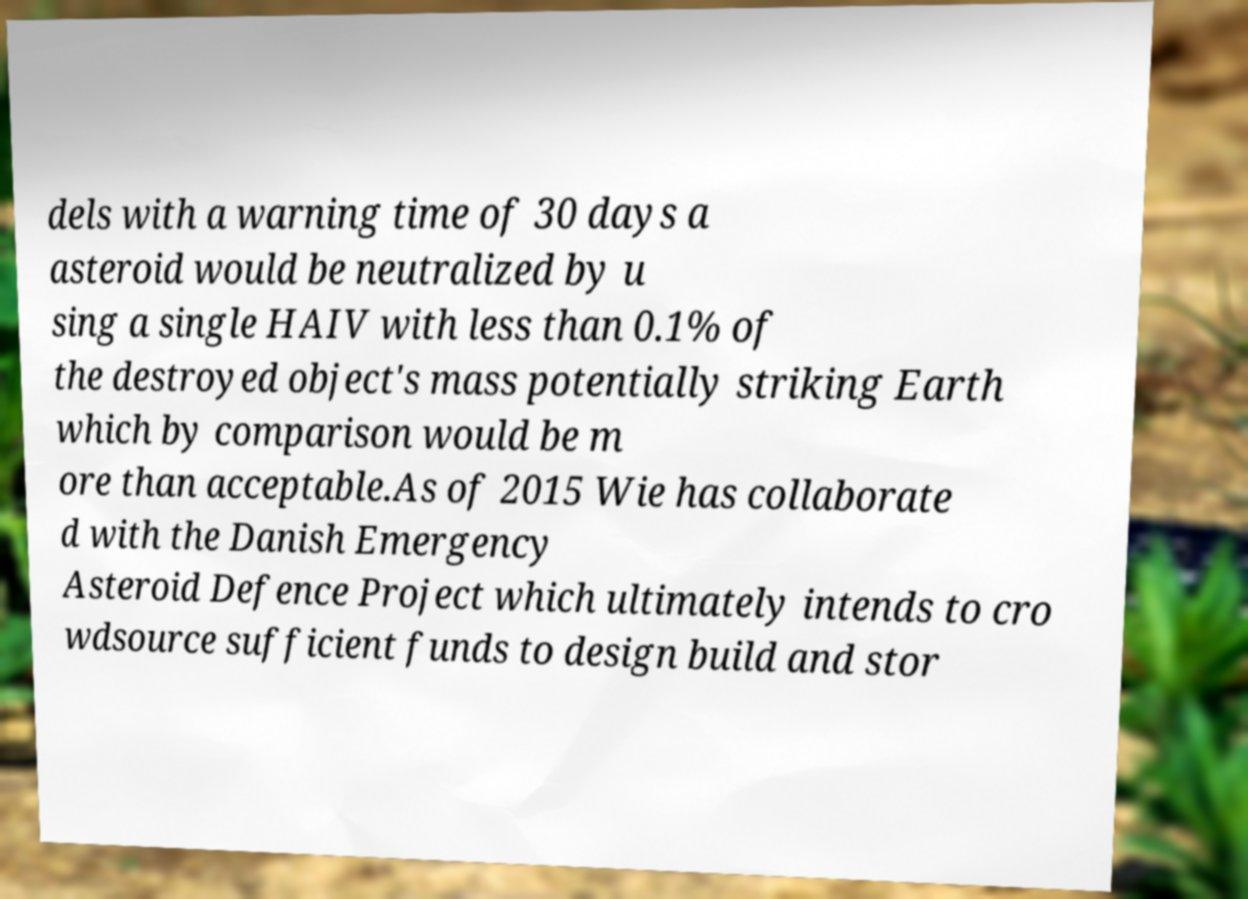Could you extract and type out the text from this image? dels with a warning time of 30 days a asteroid would be neutralized by u sing a single HAIV with less than 0.1% of the destroyed object's mass potentially striking Earth which by comparison would be m ore than acceptable.As of 2015 Wie has collaborate d with the Danish Emergency Asteroid Defence Project which ultimately intends to cro wdsource sufficient funds to design build and stor 